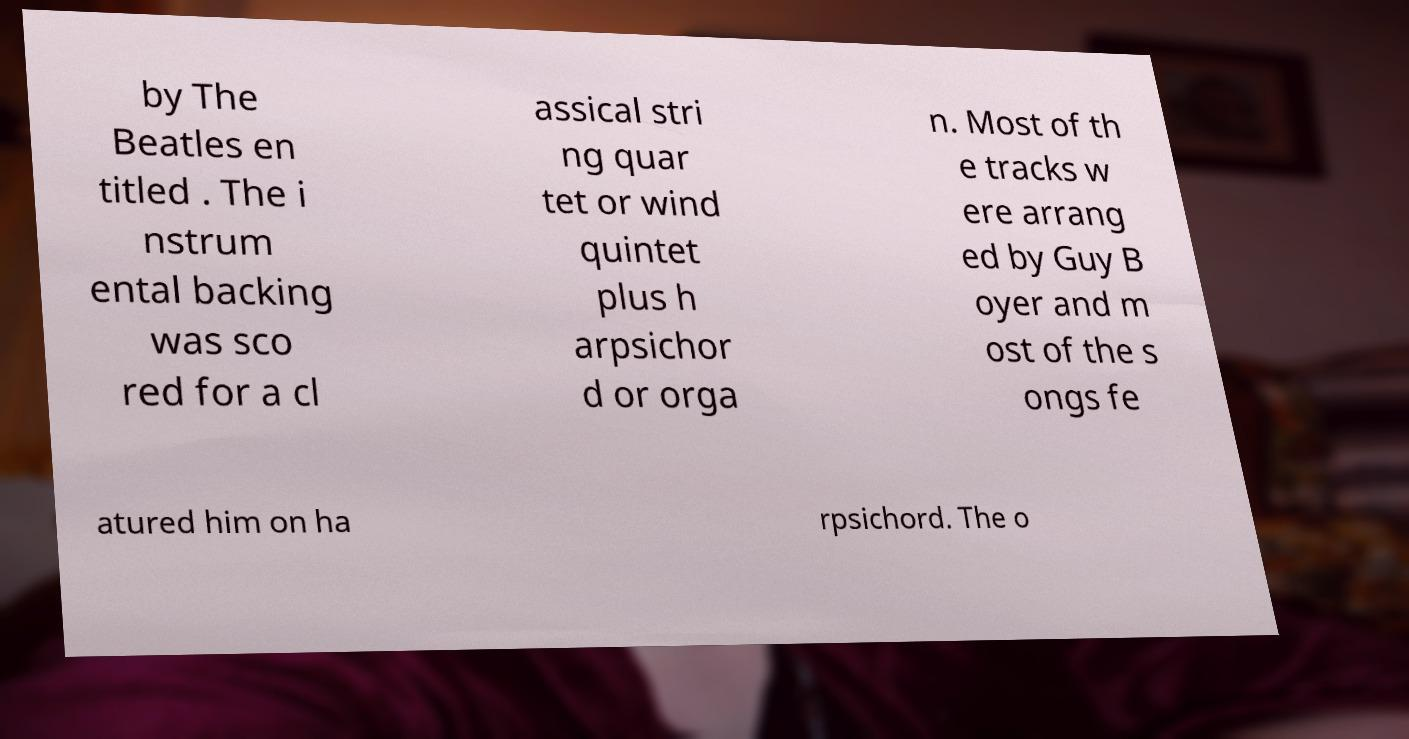Please identify and transcribe the text found in this image. by The Beatles en titled . The i nstrum ental backing was sco red for a cl assical stri ng quar tet or wind quintet plus h arpsichor d or orga n. Most of th e tracks w ere arrang ed by Guy B oyer and m ost of the s ongs fe atured him on ha rpsichord. The o 